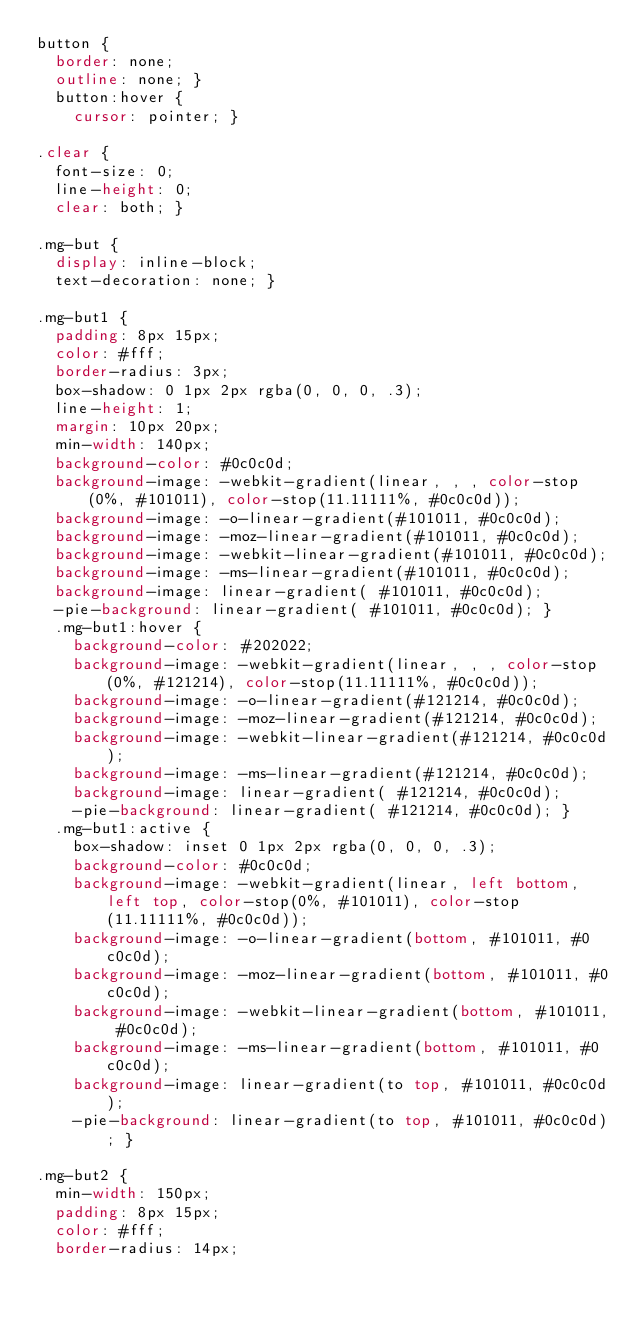<code> <loc_0><loc_0><loc_500><loc_500><_CSS_>button {
  border: none;
  outline: none; }
  button:hover {
    cursor: pointer; }

.clear {
  font-size: 0;
  line-height: 0;
  clear: both; }

.mg-but {
  display: inline-block;
  text-decoration: none; }

.mg-but1 {
  padding: 8px 15px;
  color: #fff;
  border-radius: 3px;
  box-shadow: 0 1px 2px rgba(0, 0, 0, .3);
  line-height: 1;
  margin: 10px 20px;
  min-width: 140px;
  background-color: #0c0c0d;
  background-image: -webkit-gradient(linear, , , color-stop(0%, #101011), color-stop(11.11111%, #0c0c0d));
  background-image: -o-linear-gradient(#101011, #0c0c0d);
  background-image: -moz-linear-gradient(#101011, #0c0c0d);
  background-image: -webkit-linear-gradient(#101011, #0c0c0d);
  background-image: -ms-linear-gradient(#101011, #0c0c0d);
  background-image: linear-gradient( #101011, #0c0c0d);
  -pie-background: linear-gradient( #101011, #0c0c0d); }
  .mg-but1:hover {
    background-color: #202022;
    background-image: -webkit-gradient(linear, , , color-stop(0%, #121214), color-stop(11.11111%, #0c0c0d));
    background-image: -o-linear-gradient(#121214, #0c0c0d);
    background-image: -moz-linear-gradient(#121214, #0c0c0d);
    background-image: -webkit-linear-gradient(#121214, #0c0c0d);
    background-image: -ms-linear-gradient(#121214, #0c0c0d);
    background-image: linear-gradient( #121214, #0c0c0d);
    -pie-background: linear-gradient( #121214, #0c0c0d); }
  .mg-but1:active {
    box-shadow: inset 0 1px 2px rgba(0, 0, 0, .3);
    background-color: #0c0c0d;
    background-image: -webkit-gradient(linear, left bottom, left top, color-stop(0%, #101011), color-stop(11.11111%, #0c0c0d));
    background-image: -o-linear-gradient(bottom, #101011, #0c0c0d);
    background-image: -moz-linear-gradient(bottom, #101011, #0c0c0d);
    background-image: -webkit-linear-gradient(bottom, #101011, #0c0c0d);
    background-image: -ms-linear-gradient(bottom, #101011, #0c0c0d);
    background-image: linear-gradient(to top, #101011, #0c0c0d);
    -pie-background: linear-gradient(to top, #101011, #0c0c0d); }

.mg-but2 {
  min-width: 150px;
  padding: 8px 15px;
  color: #fff;
  border-radius: 14px;</code> 